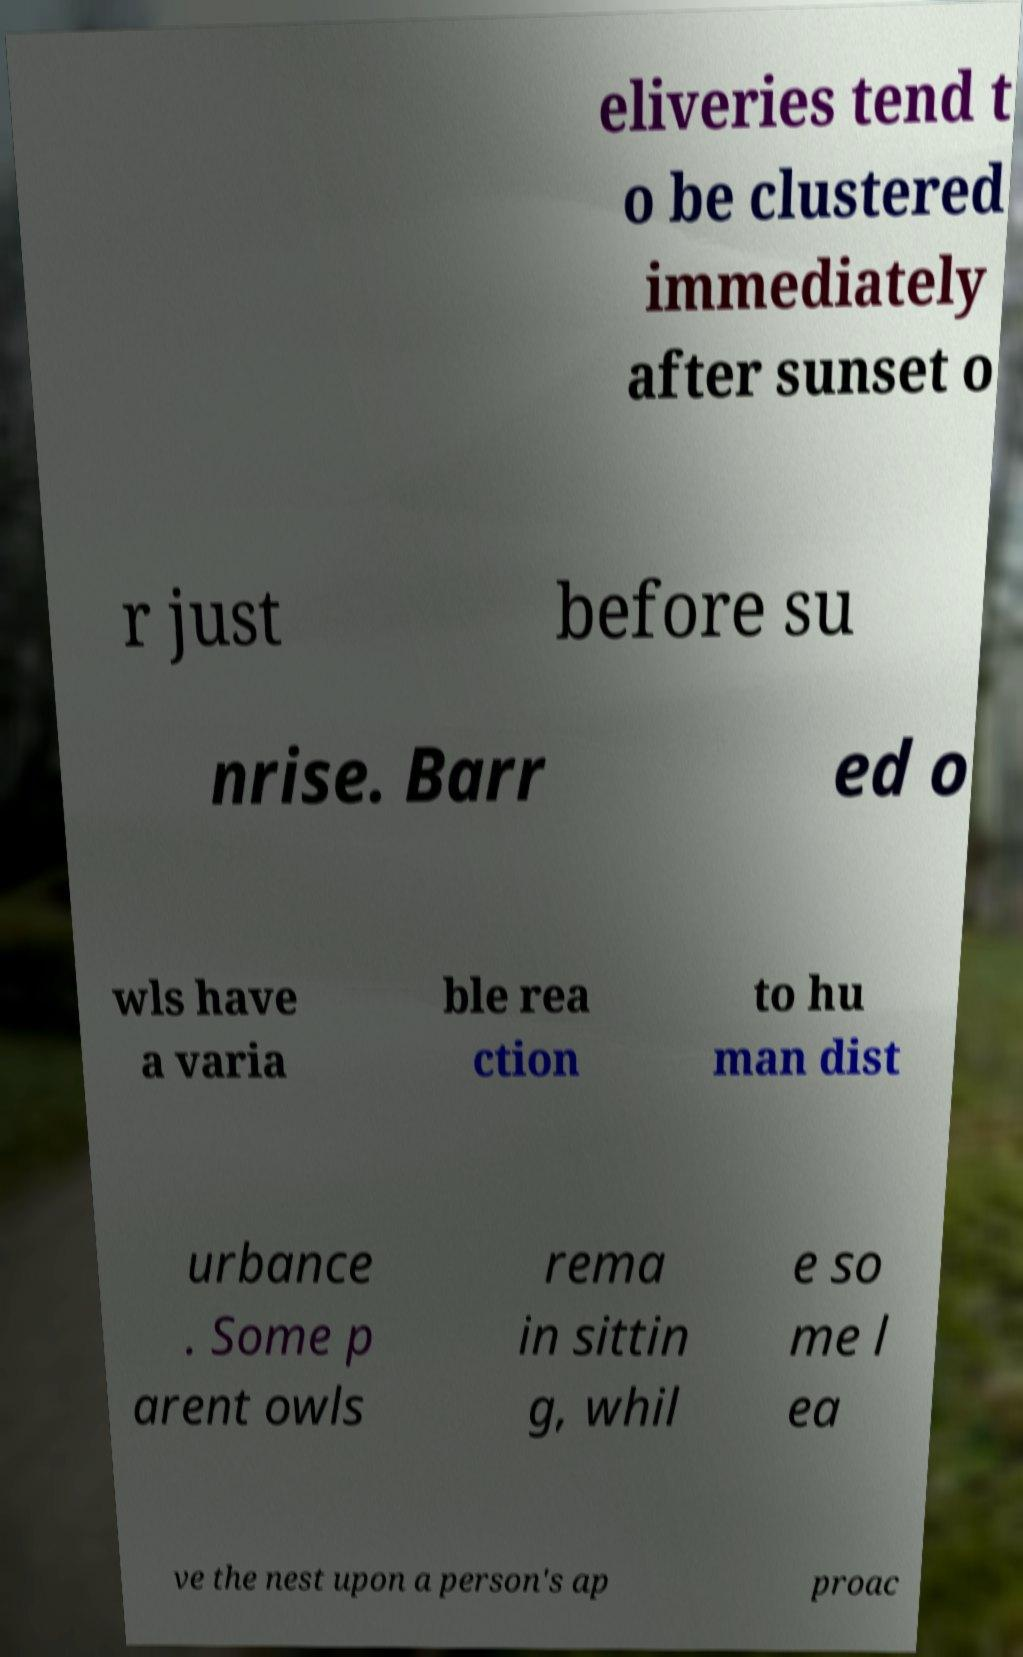Could you extract and type out the text from this image? eliveries tend t o be clustered immediately after sunset o r just before su nrise. Barr ed o wls have a varia ble rea ction to hu man dist urbance . Some p arent owls rema in sittin g, whil e so me l ea ve the nest upon a person's ap proac 